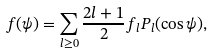Convert formula to latex. <formula><loc_0><loc_0><loc_500><loc_500>f ( \psi ) = \sum _ { l \geq 0 } \frac { 2 l + 1 } { 2 } f _ { l } P _ { l } ( \cos \psi ) ,</formula> 